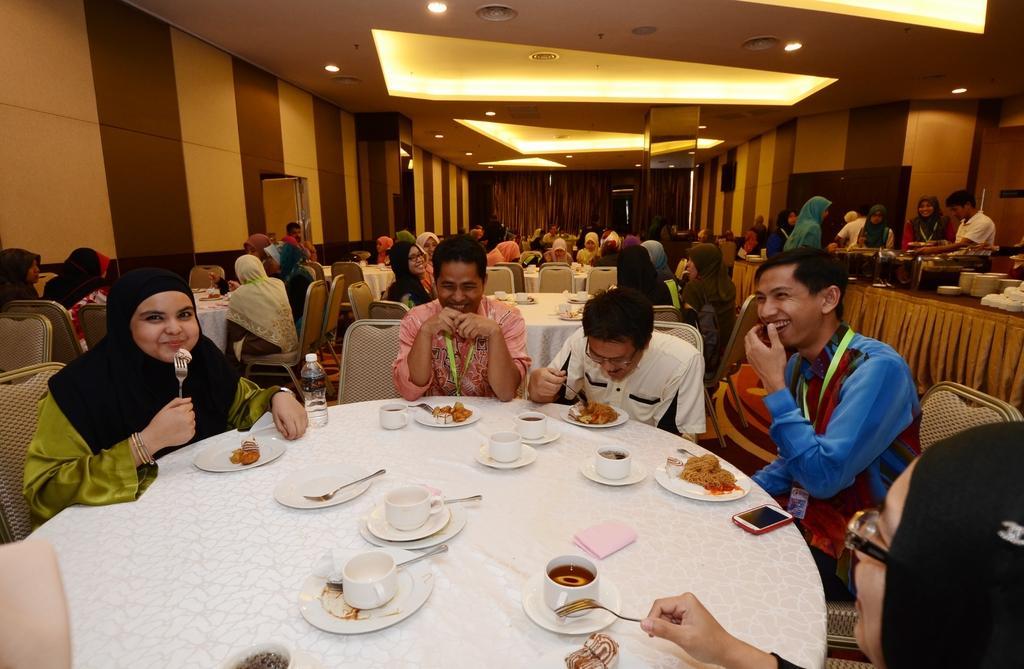Can you describe this image briefly? In this image we can see many people are sitting on the chairs around the table. We can see plate with food, cups, saucer, forks and bottles on the table. 